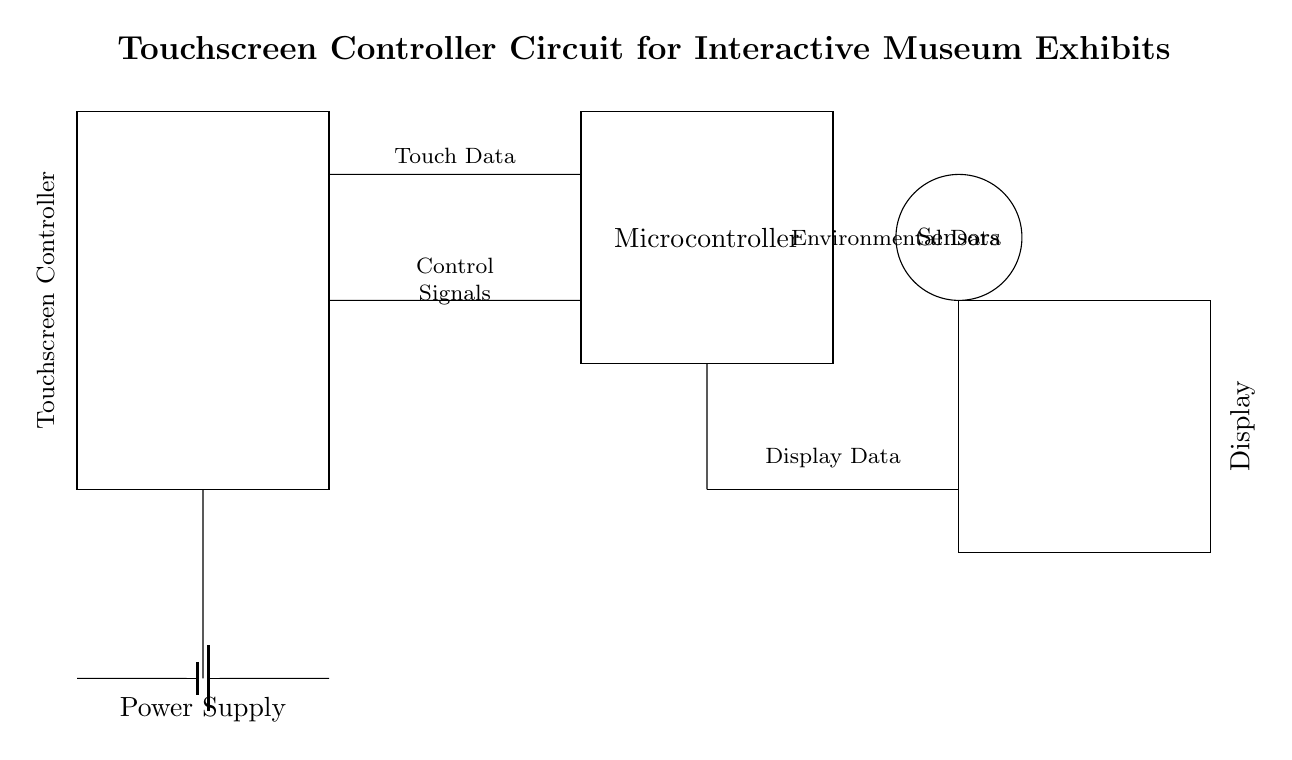What type of circuit is this? This circuit is a touchscreen controller circuit designed for interactive museum exhibits. It suggests an electronic structure that is intended for user interaction through touch.
Answer: touchscreen controller What does the power supply provide? The power supply provides the necessary voltage for the entire circuit. In this case, it supplies power to the touchscreen controller and connected components.
Answer: voltage How many main components are shown in the circuit? The circuit diagram displays four main components: the touchscreen controller, microcontroller, power supply, and display.
Answer: four Where does the display receive data from? The display receives data from the microcontroller, as indicated by the connection between the two components.
Answer: microcontroller What function do the sensors serve in the circuit? The sensors collect environmental data, which is indicated in the diagram by their label and connection to the touchscreen controller.
Answer: environmental data What is the relationship between the touchscreen controller and the microcontroller in this circuit? The touchscreen controller sends touch data and control signals to the microcontroller, which processes this information and manages the display output. Therefore, the relationship is that of input and processing.
Answer: input and processing 